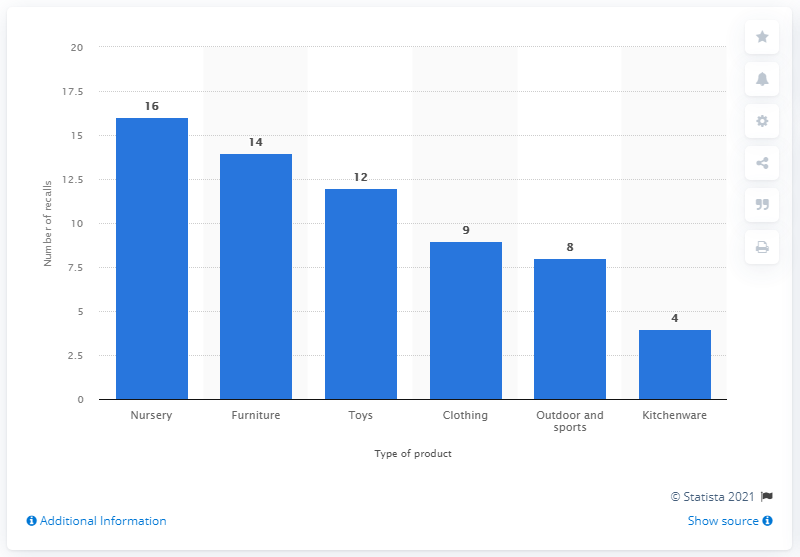Point out several critical features in this image. Out of the 63 recalled children's products, 16 were nursery products. 